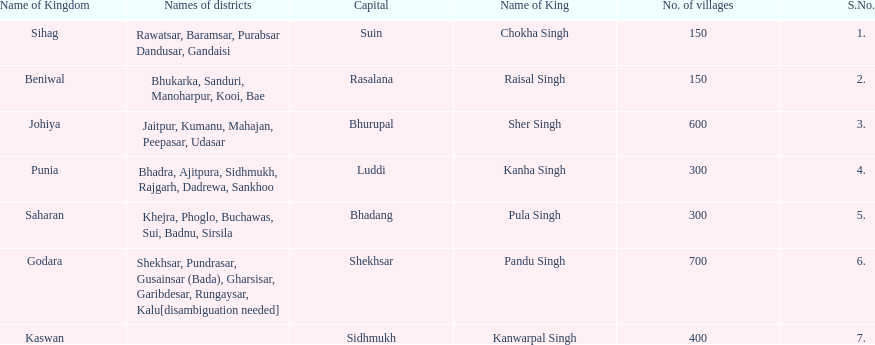Which kingdom has the most villages? Godara. 